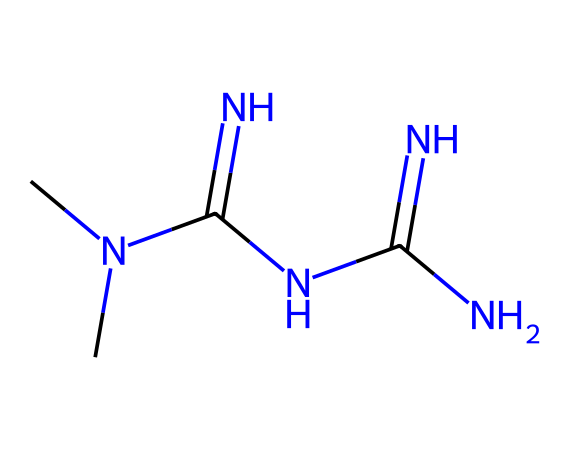What is the empirical formula of metformin? To find the empirical formula, count the atoms of each element in the molecular structure. The SMILES representation shows two carbon (C) atoms, seven hydrogen (H) atoms, and five nitrogen (N) atoms. Therefore, the empirical formula is CH3N5.
Answer: CH3N5 How many nitrogen atoms are present in metformin? By analyzing the SMILES representation, we can see that there are five nitrogen (N) atoms in the structure indicated by the 'N' symbols.
Answer: five What functional group is prevalent in metformin? The presence of multiple nitrogen atoms is characteristic of amines. In metformin, the N-C bond indicates that it contains amine functional groups. The structure contains various forms of amine, specifically guanidine groups.
Answer: amine Does metformin contain any double bonds? Looking at the SMILES representation, we see 'C(=N)', which indicates a carbon-nitrogen double bond. Confirming further through the structure reveals this double bond exists, hence there are double bonds present in metformin.
Answer: yes What type of nitrogen bonding dominates in metformin? Analyzing the SMILES, we see that three nitrogen atoms are bonded directly to carbon in single bonds, and others participate in double bonds. The structure reveals predominantly amine and guanidine types of bonding.
Answer: guanidine What is the total number of carbon atoms in metformin's structure? The SMILES representation shows two 'C' symbols, directly indicating that there are two carbon atoms present in the structure.
Answer: two 